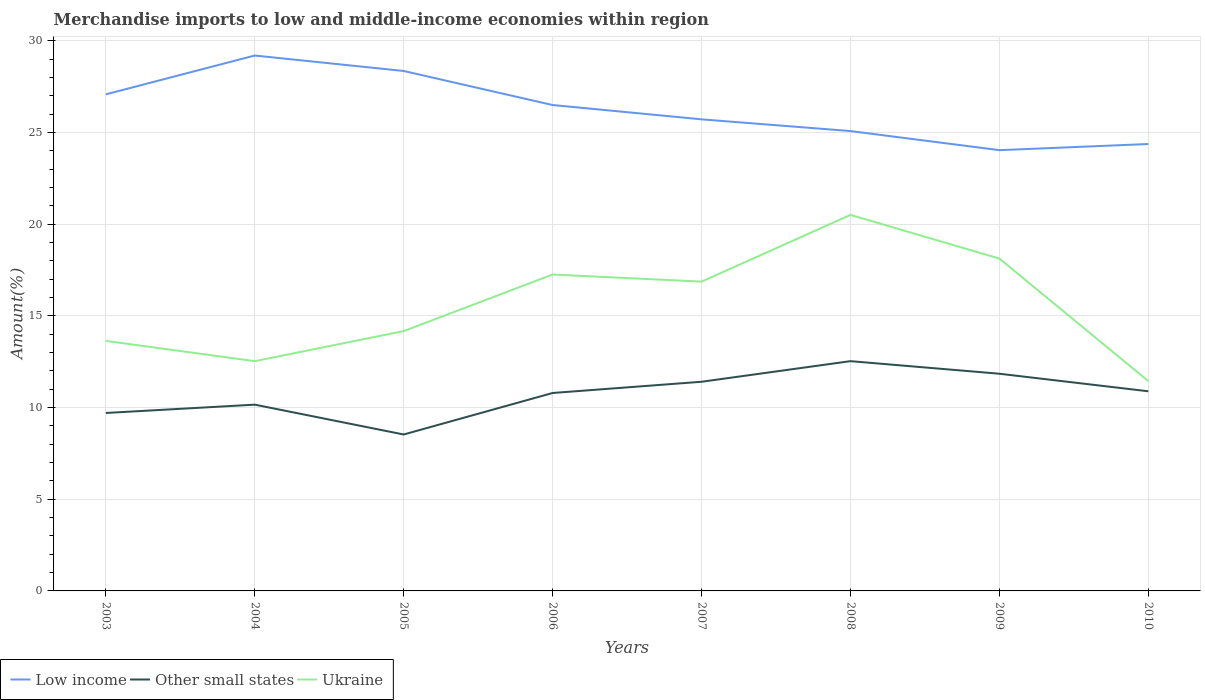How many different coloured lines are there?
Provide a short and direct response. 3. Across all years, what is the maximum percentage of amount earned from merchandise imports in Other small states?
Ensure brevity in your answer.  8.53. What is the total percentage of amount earned from merchandise imports in Ukraine in the graph?
Offer a very short reply. -3.95. What is the difference between the highest and the second highest percentage of amount earned from merchandise imports in Low income?
Your answer should be compact. 5.16. What is the difference between the highest and the lowest percentage of amount earned from merchandise imports in Ukraine?
Make the answer very short. 4. Is the percentage of amount earned from merchandise imports in Low income strictly greater than the percentage of amount earned from merchandise imports in Other small states over the years?
Offer a very short reply. No. Are the values on the major ticks of Y-axis written in scientific E-notation?
Give a very brief answer. No. Does the graph contain any zero values?
Your answer should be compact. No. Does the graph contain grids?
Your answer should be compact. Yes. Where does the legend appear in the graph?
Provide a succinct answer. Bottom left. How many legend labels are there?
Offer a very short reply. 3. What is the title of the graph?
Provide a short and direct response. Merchandise imports to low and middle-income economies within region. What is the label or title of the Y-axis?
Offer a very short reply. Amount(%). What is the Amount(%) of Low income in 2003?
Provide a short and direct response. 27.07. What is the Amount(%) of Other small states in 2003?
Keep it short and to the point. 9.7. What is the Amount(%) of Ukraine in 2003?
Offer a very short reply. 13.63. What is the Amount(%) in Low income in 2004?
Your response must be concise. 29.19. What is the Amount(%) of Other small states in 2004?
Your answer should be compact. 10.16. What is the Amount(%) in Ukraine in 2004?
Make the answer very short. 12.53. What is the Amount(%) of Low income in 2005?
Keep it short and to the point. 28.35. What is the Amount(%) in Other small states in 2005?
Provide a succinct answer. 8.53. What is the Amount(%) of Ukraine in 2005?
Your answer should be very brief. 14.17. What is the Amount(%) in Low income in 2006?
Make the answer very short. 26.49. What is the Amount(%) of Other small states in 2006?
Give a very brief answer. 10.79. What is the Amount(%) in Ukraine in 2006?
Give a very brief answer. 17.25. What is the Amount(%) of Low income in 2007?
Ensure brevity in your answer.  25.71. What is the Amount(%) in Other small states in 2007?
Your answer should be very brief. 11.4. What is the Amount(%) in Ukraine in 2007?
Ensure brevity in your answer.  16.86. What is the Amount(%) in Low income in 2008?
Your answer should be compact. 25.07. What is the Amount(%) in Other small states in 2008?
Your answer should be very brief. 12.53. What is the Amount(%) in Ukraine in 2008?
Ensure brevity in your answer.  20.5. What is the Amount(%) of Low income in 2009?
Keep it short and to the point. 24.03. What is the Amount(%) in Other small states in 2009?
Provide a short and direct response. 11.84. What is the Amount(%) of Ukraine in 2009?
Provide a short and direct response. 18.12. What is the Amount(%) of Low income in 2010?
Offer a very short reply. 24.37. What is the Amount(%) in Other small states in 2010?
Give a very brief answer. 10.88. What is the Amount(%) in Ukraine in 2010?
Provide a short and direct response. 11.44. Across all years, what is the maximum Amount(%) of Low income?
Make the answer very short. 29.19. Across all years, what is the maximum Amount(%) in Other small states?
Your answer should be compact. 12.53. Across all years, what is the maximum Amount(%) in Ukraine?
Provide a succinct answer. 20.5. Across all years, what is the minimum Amount(%) of Low income?
Offer a very short reply. 24.03. Across all years, what is the minimum Amount(%) of Other small states?
Make the answer very short. 8.53. Across all years, what is the minimum Amount(%) in Ukraine?
Your response must be concise. 11.44. What is the total Amount(%) of Low income in the graph?
Your answer should be compact. 210.29. What is the total Amount(%) in Other small states in the graph?
Offer a very short reply. 85.83. What is the total Amount(%) of Ukraine in the graph?
Offer a terse response. 124.5. What is the difference between the Amount(%) in Low income in 2003 and that in 2004?
Keep it short and to the point. -2.12. What is the difference between the Amount(%) in Other small states in 2003 and that in 2004?
Your answer should be compact. -0.45. What is the difference between the Amount(%) in Ukraine in 2003 and that in 2004?
Provide a succinct answer. 1.11. What is the difference between the Amount(%) in Low income in 2003 and that in 2005?
Make the answer very short. -1.27. What is the difference between the Amount(%) in Other small states in 2003 and that in 2005?
Make the answer very short. 1.17. What is the difference between the Amount(%) of Ukraine in 2003 and that in 2005?
Offer a terse response. -0.53. What is the difference between the Amount(%) in Low income in 2003 and that in 2006?
Your answer should be compact. 0.58. What is the difference between the Amount(%) in Other small states in 2003 and that in 2006?
Make the answer very short. -1.09. What is the difference between the Amount(%) in Ukraine in 2003 and that in 2006?
Your answer should be compact. -3.62. What is the difference between the Amount(%) in Low income in 2003 and that in 2007?
Ensure brevity in your answer.  1.36. What is the difference between the Amount(%) of Other small states in 2003 and that in 2007?
Ensure brevity in your answer.  -1.7. What is the difference between the Amount(%) in Ukraine in 2003 and that in 2007?
Your answer should be very brief. -3.23. What is the difference between the Amount(%) of Low income in 2003 and that in 2008?
Keep it short and to the point. 2. What is the difference between the Amount(%) in Other small states in 2003 and that in 2008?
Ensure brevity in your answer.  -2.83. What is the difference between the Amount(%) of Ukraine in 2003 and that in 2008?
Your response must be concise. -6.87. What is the difference between the Amount(%) of Low income in 2003 and that in 2009?
Ensure brevity in your answer.  3.04. What is the difference between the Amount(%) of Other small states in 2003 and that in 2009?
Make the answer very short. -2.14. What is the difference between the Amount(%) in Ukraine in 2003 and that in 2009?
Your response must be concise. -4.49. What is the difference between the Amount(%) in Low income in 2003 and that in 2010?
Your answer should be compact. 2.71. What is the difference between the Amount(%) of Other small states in 2003 and that in 2010?
Keep it short and to the point. -1.18. What is the difference between the Amount(%) of Ukraine in 2003 and that in 2010?
Your answer should be very brief. 2.2. What is the difference between the Amount(%) of Low income in 2004 and that in 2005?
Your response must be concise. 0.84. What is the difference between the Amount(%) of Other small states in 2004 and that in 2005?
Keep it short and to the point. 1.63. What is the difference between the Amount(%) in Ukraine in 2004 and that in 2005?
Provide a short and direct response. -1.64. What is the difference between the Amount(%) of Low income in 2004 and that in 2006?
Offer a very short reply. 2.7. What is the difference between the Amount(%) of Other small states in 2004 and that in 2006?
Keep it short and to the point. -0.64. What is the difference between the Amount(%) in Ukraine in 2004 and that in 2006?
Make the answer very short. -4.72. What is the difference between the Amount(%) in Low income in 2004 and that in 2007?
Provide a succinct answer. 3.48. What is the difference between the Amount(%) of Other small states in 2004 and that in 2007?
Ensure brevity in your answer.  -1.25. What is the difference between the Amount(%) of Ukraine in 2004 and that in 2007?
Your answer should be compact. -4.34. What is the difference between the Amount(%) in Low income in 2004 and that in 2008?
Offer a terse response. 4.12. What is the difference between the Amount(%) of Other small states in 2004 and that in 2008?
Your response must be concise. -2.37. What is the difference between the Amount(%) of Ukraine in 2004 and that in 2008?
Your response must be concise. -7.97. What is the difference between the Amount(%) of Low income in 2004 and that in 2009?
Ensure brevity in your answer.  5.16. What is the difference between the Amount(%) of Other small states in 2004 and that in 2009?
Ensure brevity in your answer.  -1.69. What is the difference between the Amount(%) of Ukraine in 2004 and that in 2009?
Your answer should be very brief. -5.59. What is the difference between the Amount(%) in Low income in 2004 and that in 2010?
Provide a short and direct response. 4.82. What is the difference between the Amount(%) in Other small states in 2004 and that in 2010?
Provide a short and direct response. -0.73. What is the difference between the Amount(%) in Ukraine in 2004 and that in 2010?
Your response must be concise. 1.09. What is the difference between the Amount(%) in Low income in 2005 and that in 2006?
Give a very brief answer. 1.86. What is the difference between the Amount(%) in Other small states in 2005 and that in 2006?
Your response must be concise. -2.26. What is the difference between the Amount(%) in Ukraine in 2005 and that in 2006?
Make the answer very short. -3.08. What is the difference between the Amount(%) in Low income in 2005 and that in 2007?
Keep it short and to the point. 2.64. What is the difference between the Amount(%) of Other small states in 2005 and that in 2007?
Provide a succinct answer. -2.88. What is the difference between the Amount(%) of Ukraine in 2005 and that in 2007?
Provide a succinct answer. -2.7. What is the difference between the Amount(%) in Low income in 2005 and that in 2008?
Your response must be concise. 3.28. What is the difference between the Amount(%) in Other small states in 2005 and that in 2008?
Your response must be concise. -4. What is the difference between the Amount(%) of Ukraine in 2005 and that in 2008?
Provide a short and direct response. -6.33. What is the difference between the Amount(%) in Low income in 2005 and that in 2009?
Provide a short and direct response. 4.32. What is the difference between the Amount(%) of Other small states in 2005 and that in 2009?
Your answer should be very brief. -3.31. What is the difference between the Amount(%) of Ukraine in 2005 and that in 2009?
Give a very brief answer. -3.95. What is the difference between the Amount(%) in Low income in 2005 and that in 2010?
Ensure brevity in your answer.  3.98. What is the difference between the Amount(%) in Other small states in 2005 and that in 2010?
Ensure brevity in your answer.  -2.36. What is the difference between the Amount(%) of Ukraine in 2005 and that in 2010?
Offer a very short reply. 2.73. What is the difference between the Amount(%) of Low income in 2006 and that in 2007?
Ensure brevity in your answer.  0.78. What is the difference between the Amount(%) in Other small states in 2006 and that in 2007?
Your answer should be very brief. -0.61. What is the difference between the Amount(%) in Ukraine in 2006 and that in 2007?
Your answer should be very brief. 0.39. What is the difference between the Amount(%) in Low income in 2006 and that in 2008?
Give a very brief answer. 1.42. What is the difference between the Amount(%) of Other small states in 2006 and that in 2008?
Offer a very short reply. -1.74. What is the difference between the Amount(%) in Ukraine in 2006 and that in 2008?
Offer a terse response. -3.25. What is the difference between the Amount(%) of Low income in 2006 and that in 2009?
Your answer should be compact. 2.46. What is the difference between the Amount(%) in Other small states in 2006 and that in 2009?
Your answer should be compact. -1.05. What is the difference between the Amount(%) in Ukraine in 2006 and that in 2009?
Offer a terse response. -0.87. What is the difference between the Amount(%) of Low income in 2006 and that in 2010?
Give a very brief answer. 2.13. What is the difference between the Amount(%) in Other small states in 2006 and that in 2010?
Your answer should be compact. -0.09. What is the difference between the Amount(%) of Ukraine in 2006 and that in 2010?
Make the answer very short. 5.81. What is the difference between the Amount(%) in Low income in 2007 and that in 2008?
Provide a short and direct response. 0.64. What is the difference between the Amount(%) in Other small states in 2007 and that in 2008?
Your answer should be very brief. -1.12. What is the difference between the Amount(%) in Ukraine in 2007 and that in 2008?
Make the answer very short. -3.64. What is the difference between the Amount(%) of Low income in 2007 and that in 2009?
Offer a very short reply. 1.68. What is the difference between the Amount(%) of Other small states in 2007 and that in 2009?
Ensure brevity in your answer.  -0.44. What is the difference between the Amount(%) of Ukraine in 2007 and that in 2009?
Make the answer very short. -1.26. What is the difference between the Amount(%) in Low income in 2007 and that in 2010?
Make the answer very short. 1.35. What is the difference between the Amount(%) in Other small states in 2007 and that in 2010?
Your answer should be compact. 0.52. What is the difference between the Amount(%) in Ukraine in 2007 and that in 2010?
Offer a terse response. 5.43. What is the difference between the Amount(%) of Low income in 2008 and that in 2009?
Your response must be concise. 1.04. What is the difference between the Amount(%) in Other small states in 2008 and that in 2009?
Your answer should be compact. 0.69. What is the difference between the Amount(%) of Ukraine in 2008 and that in 2009?
Give a very brief answer. 2.38. What is the difference between the Amount(%) of Low income in 2008 and that in 2010?
Give a very brief answer. 0.71. What is the difference between the Amount(%) in Other small states in 2008 and that in 2010?
Offer a terse response. 1.64. What is the difference between the Amount(%) of Ukraine in 2008 and that in 2010?
Ensure brevity in your answer.  9.06. What is the difference between the Amount(%) of Low income in 2009 and that in 2010?
Keep it short and to the point. -0.33. What is the difference between the Amount(%) in Other small states in 2009 and that in 2010?
Offer a terse response. 0.96. What is the difference between the Amount(%) in Ukraine in 2009 and that in 2010?
Offer a terse response. 6.68. What is the difference between the Amount(%) in Low income in 2003 and the Amount(%) in Other small states in 2004?
Make the answer very short. 16.92. What is the difference between the Amount(%) of Low income in 2003 and the Amount(%) of Ukraine in 2004?
Ensure brevity in your answer.  14.55. What is the difference between the Amount(%) in Other small states in 2003 and the Amount(%) in Ukraine in 2004?
Keep it short and to the point. -2.82. What is the difference between the Amount(%) in Low income in 2003 and the Amount(%) in Other small states in 2005?
Your response must be concise. 18.55. What is the difference between the Amount(%) of Low income in 2003 and the Amount(%) of Ukraine in 2005?
Your answer should be compact. 12.91. What is the difference between the Amount(%) in Other small states in 2003 and the Amount(%) in Ukraine in 2005?
Your response must be concise. -4.47. What is the difference between the Amount(%) of Low income in 2003 and the Amount(%) of Other small states in 2006?
Your answer should be very brief. 16.28. What is the difference between the Amount(%) of Low income in 2003 and the Amount(%) of Ukraine in 2006?
Offer a very short reply. 9.82. What is the difference between the Amount(%) in Other small states in 2003 and the Amount(%) in Ukraine in 2006?
Your response must be concise. -7.55. What is the difference between the Amount(%) of Low income in 2003 and the Amount(%) of Other small states in 2007?
Provide a succinct answer. 15.67. What is the difference between the Amount(%) of Low income in 2003 and the Amount(%) of Ukraine in 2007?
Your response must be concise. 10.21. What is the difference between the Amount(%) of Other small states in 2003 and the Amount(%) of Ukraine in 2007?
Provide a short and direct response. -7.16. What is the difference between the Amount(%) of Low income in 2003 and the Amount(%) of Other small states in 2008?
Provide a short and direct response. 14.55. What is the difference between the Amount(%) in Low income in 2003 and the Amount(%) in Ukraine in 2008?
Offer a terse response. 6.57. What is the difference between the Amount(%) in Other small states in 2003 and the Amount(%) in Ukraine in 2008?
Offer a very short reply. -10.8. What is the difference between the Amount(%) of Low income in 2003 and the Amount(%) of Other small states in 2009?
Make the answer very short. 15.23. What is the difference between the Amount(%) of Low income in 2003 and the Amount(%) of Ukraine in 2009?
Provide a short and direct response. 8.95. What is the difference between the Amount(%) in Other small states in 2003 and the Amount(%) in Ukraine in 2009?
Provide a succinct answer. -8.42. What is the difference between the Amount(%) in Low income in 2003 and the Amount(%) in Other small states in 2010?
Give a very brief answer. 16.19. What is the difference between the Amount(%) of Low income in 2003 and the Amount(%) of Ukraine in 2010?
Your answer should be compact. 15.64. What is the difference between the Amount(%) in Other small states in 2003 and the Amount(%) in Ukraine in 2010?
Keep it short and to the point. -1.74. What is the difference between the Amount(%) of Low income in 2004 and the Amount(%) of Other small states in 2005?
Give a very brief answer. 20.66. What is the difference between the Amount(%) in Low income in 2004 and the Amount(%) in Ukraine in 2005?
Keep it short and to the point. 15.02. What is the difference between the Amount(%) of Other small states in 2004 and the Amount(%) of Ukraine in 2005?
Your answer should be very brief. -4.01. What is the difference between the Amount(%) in Low income in 2004 and the Amount(%) in Other small states in 2006?
Offer a very short reply. 18.4. What is the difference between the Amount(%) in Low income in 2004 and the Amount(%) in Ukraine in 2006?
Give a very brief answer. 11.94. What is the difference between the Amount(%) in Other small states in 2004 and the Amount(%) in Ukraine in 2006?
Provide a succinct answer. -7.09. What is the difference between the Amount(%) in Low income in 2004 and the Amount(%) in Other small states in 2007?
Make the answer very short. 17.79. What is the difference between the Amount(%) in Low income in 2004 and the Amount(%) in Ukraine in 2007?
Give a very brief answer. 12.33. What is the difference between the Amount(%) in Other small states in 2004 and the Amount(%) in Ukraine in 2007?
Provide a short and direct response. -6.71. What is the difference between the Amount(%) of Low income in 2004 and the Amount(%) of Other small states in 2008?
Make the answer very short. 16.66. What is the difference between the Amount(%) in Low income in 2004 and the Amount(%) in Ukraine in 2008?
Provide a short and direct response. 8.69. What is the difference between the Amount(%) in Other small states in 2004 and the Amount(%) in Ukraine in 2008?
Offer a terse response. -10.35. What is the difference between the Amount(%) in Low income in 2004 and the Amount(%) in Other small states in 2009?
Give a very brief answer. 17.35. What is the difference between the Amount(%) in Low income in 2004 and the Amount(%) in Ukraine in 2009?
Keep it short and to the point. 11.07. What is the difference between the Amount(%) of Other small states in 2004 and the Amount(%) of Ukraine in 2009?
Your answer should be very brief. -7.96. What is the difference between the Amount(%) in Low income in 2004 and the Amount(%) in Other small states in 2010?
Offer a terse response. 18.31. What is the difference between the Amount(%) of Low income in 2004 and the Amount(%) of Ukraine in 2010?
Provide a succinct answer. 17.75. What is the difference between the Amount(%) of Other small states in 2004 and the Amount(%) of Ukraine in 2010?
Ensure brevity in your answer.  -1.28. What is the difference between the Amount(%) in Low income in 2005 and the Amount(%) in Other small states in 2006?
Your response must be concise. 17.56. What is the difference between the Amount(%) in Low income in 2005 and the Amount(%) in Ukraine in 2006?
Give a very brief answer. 11.1. What is the difference between the Amount(%) in Other small states in 2005 and the Amount(%) in Ukraine in 2006?
Your response must be concise. -8.72. What is the difference between the Amount(%) of Low income in 2005 and the Amount(%) of Other small states in 2007?
Provide a short and direct response. 16.94. What is the difference between the Amount(%) of Low income in 2005 and the Amount(%) of Ukraine in 2007?
Provide a short and direct response. 11.48. What is the difference between the Amount(%) of Other small states in 2005 and the Amount(%) of Ukraine in 2007?
Ensure brevity in your answer.  -8.34. What is the difference between the Amount(%) of Low income in 2005 and the Amount(%) of Other small states in 2008?
Offer a terse response. 15.82. What is the difference between the Amount(%) of Low income in 2005 and the Amount(%) of Ukraine in 2008?
Your answer should be very brief. 7.85. What is the difference between the Amount(%) in Other small states in 2005 and the Amount(%) in Ukraine in 2008?
Your answer should be compact. -11.97. What is the difference between the Amount(%) in Low income in 2005 and the Amount(%) in Other small states in 2009?
Give a very brief answer. 16.51. What is the difference between the Amount(%) of Low income in 2005 and the Amount(%) of Ukraine in 2009?
Your response must be concise. 10.23. What is the difference between the Amount(%) of Other small states in 2005 and the Amount(%) of Ukraine in 2009?
Give a very brief answer. -9.59. What is the difference between the Amount(%) of Low income in 2005 and the Amount(%) of Other small states in 2010?
Keep it short and to the point. 17.46. What is the difference between the Amount(%) of Low income in 2005 and the Amount(%) of Ukraine in 2010?
Give a very brief answer. 16.91. What is the difference between the Amount(%) in Other small states in 2005 and the Amount(%) in Ukraine in 2010?
Your answer should be compact. -2.91. What is the difference between the Amount(%) of Low income in 2006 and the Amount(%) of Other small states in 2007?
Your response must be concise. 15.09. What is the difference between the Amount(%) in Low income in 2006 and the Amount(%) in Ukraine in 2007?
Your answer should be very brief. 9.63. What is the difference between the Amount(%) in Other small states in 2006 and the Amount(%) in Ukraine in 2007?
Your answer should be compact. -6.07. What is the difference between the Amount(%) of Low income in 2006 and the Amount(%) of Other small states in 2008?
Your answer should be very brief. 13.96. What is the difference between the Amount(%) of Low income in 2006 and the Amount(%) of Ukraine in 2008?
Offer a terse response. 5.99. What is the difference between the Amount(%) of Other small states in 2006 and the Amount(%) of Ukraine in 2008?
Your answer should be very brief. -9.71. What is the difference between the Amount(%) of Low income in 2006 and the Amount(%) of Other small states in 2009?
Your response must be concise. 14.65. What is the difference between the Amount(%) of Low income in 2006 and the Amount(%) of Ukraine in 2009?
Make the answer very short. 8.37. What is the difference between the Amount(%) of Other small states in 2006 and the Amount(%) of Ukraine in 2009?
Provide a short and direct response. -7.33. What is the difference between the Amount(%) in Low income in 2006 and the Amount(%) in Other small states in 2010?
Your answer should be compact. 15.61. What is the difference between the Amount(%) in Low income in 2006 and the Amount(%) in Ukraine in 2010?
Keep it short and to the point. 15.05. What is the difference between the Amount(%) in Other small states in 2006 and the Amount(%) in Ukraine in 2010?
Provide a succinct answer. -0.65. What is the difference between the Amount(%) in Low income in 2007 and the Amount(%) in Other small states in 2008?
Your answer should be very brief. 13.18. What is the difference between the Amount(%) in Low income in 2007 and the Amount(%) in Ukraine in 2008?
Your response must be concise. 5.21. What is the difference between the Amount(%) in Other small states in 2007 and the Amount(%) in Ukraine in 2008?
Offer a terse response. -9.1. What is the difference between the Amount(%) in Low income in 2007 and the Amount(%) in Other small states in 2009?
Your answer should be very brief. 13.87. What is the difference between the Amount(%) in Low income in 2007 and the Amount(%) in Ukraine in 2009?
Your response must be concise. 7.59. What is the difference between the Amount(%) in Other small states in 2007 and the Amount(%) in Ukraine in 2009?
Offer a very short reply. -6.72. What is the difference between the Amount(%) in Low income in 2007 and the Amount(%) in Other small states in 2010?
Your answer should be very brief. 14.83. What is the difference between the Amount(%) of Low income in 2007 and the Amount(%) of Ukraine in 2010?
Offer a terse response. 14.27. What is the difference between the Amount(%) of Other small states in 2007 and the Amount(%) of Ukraine in 2010?
Offer a very short reply. -0.03. What is the difference between the Amount(%) in Low income in 2008 and the Amount(%) in Other small states in 2009?
Your answer should be compact. 13.23. What is the difference between the Amount(%) in Low income in 2008 and the Amount(%) in Ukraine in 2009?
Your response must be concise. 6.95. What is the difference between the Amount(%) of Other small states in 2008 and the Amount(%) of Ukraine in 2009?
Give a very brief answer. -5.59. What is the difference between the Amount(%) of Low income in 2008 and the Amount(%) of Other small states in 2010?
Provide a succinct answer. 14.19. What is the difference between the Amount(%) in Low income in 2008 and the Amount(%) in Ukraine in 2010?
Your answer should be compact. 13.64. What is the difference between the Amount(%) of Other small states in 2008 and the Amount(%) of Ukraine in 2010?
Provide a short and direct response. 1.09. What is the difference between the Amount(%) of Low income in 2009 and the Amount(%) of Other small states in 2010?
Make the answer very short. 13.15. What is the difference between the Amount(%) of Low income in 2009 and the Amount(%) of Ukraine in 2010?
Keep it short and to the point. 12.59. What is the difference between the Amount(%) in Other small states in 2009 and the Amount(%) in Ukraine in 2010?
Provide a succinct answer. 0.4. What is the average Amount(%) of Low income per year?
Offer a very short reply. 26.29. What is the average Amount(%) in Other small states per year?
Ensure brevity in your answer.  10.73. What is the average Amount(%) in Ukraine per year?
Your response must be concise. 15.56. In the year 2003, what is the difference between the Amount(%) in Low income and Amount(%) in Other small states?
Give a very brief answer. 17.37. In the year 2003, what is the difference between the Amount(%) of Low income and Amount(%) of Ukraine?
Give a very brief answer. 13.44. In the year 2003, what is the difference between the Amount(%) of Other small states and Amount(%) of Ukraine?
Offer a terse response. -3.93. In the year 2004, what is the difference between the Amount(%) in Low income and Amount(%) in Other small states?
Your response must be concise. 19.04. In the year 2004, what is the difference between the Amount(%) in Low income and Amount(%) in Ukraine?
Offer a terse response. 16.66. In the year 2004, what is the difference between the Amount(%) of Other small states and Amount(%) of Ukraine?
Your response must be concise. -2.37. In the year 2005, what is the difference between the Amount(%) in Low income and Amount(%) in Other small states?
Offer a very short reply. 19.82. In the year 2005, what is the difference between the Amount(%) in Low income and Amount(%) in Ukraine?
Your answer should be very brief. 14.18. In the year 2005, what is the difference between the Amount(%) in Other small states and Amount(%) in Ukraine?
Ensure brevity in your answer.  -5.64. In the year 2006, what is the difference between the Amount(%) of Low income and Amount(%) of Other small states?
Provide a short and direct response. 15.7. In the year 2006, what is the difference between the Amount(%) in Low income and Amount(%) in Ukraine?
Offer a terse response. 9.24. In the year 2006, what is the difference between the Amount(%) in Other small states and Amount(%) in Ukraine?
Offer a terse response. -6.46. In the year 2007, what is the difference between the Amount(%) of Low income and Amount(%) of Other small states?
Ensure brevity in your answer.  14.31. In the year 2007, what is the difference between the Amount(%) of Low income and Amount(%) of Ukraine?
Your response must be concise. 8.85. In the year 2007, what is the difference between the Amount(%) in Other small states and Amount(%) in Ukraine?
Give a very brief answer. -5.46. In the year 2008, what is the difference between the Amount(%) of Low income and Amount(%) of Other small states?
Offer a very short reply. 12.54. In the year 2008, what is the difference between the Amount(%) in Low income and Amount(%) in Ukraine?
Your response must be concise. 4.57. In the year 2008, what is the difference between the Amount(%) of Other small states and Amount(%) of Ukraine?
Your response must be concise. -7.97. In the year 2009, what is the difference between the Amount(%) of Low income and Amount(%) of Other small states?
Your answer should be compact. 12.19. In the year 2009, what is the difference between the Amount(%) in Low income and Amount(%) in Ukraine?
Provide a succinct answer. 5.91. In the year 2009, what is the difference between the Amount(%) of Other small states and Amount(%) of Ukraine?
Provide a short and direct response. -6.28. In the year 2010, what is the difference between the Amount(%) in Low income and Amount(%) in Other small states?
Provide a succinct answer. 13.48. In the year 2010, what is the difference between the Amount(%) in Low income and Amount(%) in Ukraine?
Provide a short and direct response. 12.93. In the year 2010, what is the difference between the Amount(%) of Other small states and Amount(%) of Ukraine?
Your answer should be very brief. -0.55. What is the ratio of the Amount(%) in Low income in 2003 to that in 2004?
Keep it short and to the point. 0.93. What is the ratio of the Amount(%) of Other small states in 2003 to that in 2004?
Offer a very short reply. 0.96. What is the ratio of the Amount(%) of Ukraine in 2003 to that in 2004?
Provide a short and direct response. 1.09. What is the ratio of the Amount(%) in Low income in 2003 to that in 2005?
Your answer should be compact. 0.96. What is the ratio of the Amount(%) of Other small states in 2003 to that in 2005?
Your response must be concise. 1.14. What is the ratio of the Amount(%) of Ukraine in 2003 to that in 2005?
Your response must be concise. 0.96. What is the ratio of the Amount(%) in Other small states in 2003 to that in 2006?
Your response must be concise. 0.9. What is the ratio of the Amount(%) of Ukraine in 2003 to that in 2006?
Make the answer very short. 0.79. What is the ratio of the Amount(%) of Low income in 2003 to that in 2007?
Make the answer very short. 1.05. What is the ratio of the Amount(%) of Other small states in 2003 to that in 2007?
Give a very brief answer. 0.85. What is the ratio of the Amount(%) in Ukraine in 2003 to that in 2007?
Your answer should be compact. 0.81. What is the ratio of the Amount(%) of Low income in 2003 to that in 2008?
Provide a short and direct response. 1.08. What is the ratio of the Amount(%) in Other small states in 2003 to that in 2008?
Ensure brevity in your answer.  0.77. What is the ratio of the Amount(%) in Ukraine in 2003 to that in 2008?
Your answer should be compact. 0.67. What is the ratio of the Amount(%) of Low income in 2003 to that in 2009?
Offer a terse response. 1.13. What is the ratio of the Amount(%) of Other small states in 2003 to that in 2009?
Provide a succinct answer. 0.82. What is the ratio of the Amount(%) of Ukraine in 2003 to that in 2009?
Your answer should be compact. 0.75. What is the ratio of the Amount(%) in Low income in 2003 to that in 2010?
Your answer should be compact. 1.11. What is the ratio of the Amount(%) of Other small states in 2003 to that in 2010?
Ensure brevity in your answer.  0.89. What is the ratio of the Amount(%) in Ukraine in 2003 to that in 2010?
Your answer should be very brief. 1.19. What is the ratio of the Amount(%) of Low income in 2004 to that in 2005?
Ensure brevity in your answer.  1.03. What is the ratio of the Amount(%) of Other small states in 2004 to that in 2005?
Your answer should be very brief. 1.19. What is the ratio of the Amount(%) in Ukraine in 2004 to that in 2005?
Your answer should be very brief. 0.88. What is the ratio of the Amount(%) in Low income in 2004 to that in 2006?
Your answer should be very brief. 1.1. What is the ratio of the Amount(%) in Other small states in 2004 to that in 2006?
Ensure brevity in your answer.  0.94. What is the ratio of the Amount(%) in Ukraine in 2004 to that in 2006?
Make the answer very short. 0.73. What is the ratio of the Amount(%) in Low income in 2004 to that in 2007?
Your response must be concise. 1.14. What is the ratio of the Amount(%) in Other small states in 2004 to that in 2007?
Provide a short and direct response. 0.89. What is the ratio of the Amount(%) in Ukraine in 2004 to that in 2007?
Ensure brevity in your answer.  0.74. What is the ratio of the Amount(%) in Low income in 2004 to that in 2008?
Keep it short and to the point. 1.16. What is the ratio of the Amount(%) of Other small states in 2004 to that in 2008?
Offer a terse response. 0.81. What is the ratio of the Amount(%) of Ukraine in 2004 to that in 2008?
Your answer should be compact. 0.61. What is the ratio of the Amount(%) of Low income in 2004 to that in 2009?
Your answer should be very brief. 1.21. What is the ratio of the Amount(%) of Other small states in 2004 to that in 2009?
Your answer should be very brief. 0.86. What is the ratio of the Amount(%) of Ukraine in 2004 to that in 2009?
Ensure brevity in your answer.  0.69. What is the ratio of the Amount(%) in Low income in 2004 to that in 2010?
Offer a terse response. 1.2. What is the ratio of the Amount(%) in Other small states in 2004 to that in 2010?
Provide a succinct answer. 0.93. What is the ratio of the Amount(%) in Ukraine in 2004 to that in 2010?
Provide a short and direct response. 1.1. What is the ratio of the Amount(%) of Low income in 2005 to that in 2006?
Provide a short and direct response. 1.07. What is the ratio of the Amount(%) in Other small states in 2005 to that in 2006?
Make the answer very short. 0.79. What is the ratio of the Amount(%) of Ukraine in 2005 to that in 2006?
Your answer should be very brief. 0.82. What is the ratio of the Amount(%) of Low income in 2005 to that in 2007?
Your answer should be compact. 1.1. What is the ratio of the Amount(%) of Other small states in 2005 to that in 2007?
Offer a very short reply. 0.75. What is the ratio of the Amount(%) in Ukraine in 2005 to that in 2007?
Offer a very short reply. 0.84. What is the ratio of the Amount(%) in Low income in 2005 to that in 2008?
Provide a succinct answer. 1.13. What is the ratio of the Amount(%) of Other small states in 2005 to that in 2008?
Give a very brief answer. 0.68. What is the ratio of the Amount(%) in Ukraine in 2005 to that in 2008?
Ensure brevity in your answer.  0.69. What is the ratio of the Amount(%) in Low income in 2005 to that in 2009?
Offer a very short reply. 1.18. What is the ratio of the Amount(%) of Other small states in 2005 to that in 2009?
Your answer should be very brief. 0.72. What is the ratio of the Amount(%) of Ukraine in 2005 to that in 2009?
Offer a terse response. 0.78. What is the ratio of the Amount(%) of Low income in 2005 to that in 2010?
Give a very brief answer. 1.16. What is the ratio of the Amount(%) of Other small states in 2005 to that in 2010?
Give a very brief answer. 0.78. What is the ratio of the Amount(%) of Ukraine in 2005 to that in 2010?
Make the answer very short. 1.24. What is the ratio of the Amount(%) of Low income in 2006 to that in 2007?
Make the answer very short. 1.03. What is the ratio of the Amount(%) of Other small states in 2006 to that in 2007?
Your answer should be compact. 0.95. What is the ratio of the Amount(%) of Ukraine in 2006 to that in 2007?
Offer a terse response. 1.02. What is the ratio of the Amount(%) of Low income in 2006 to that in 2008?
Provide a succinct answer. 1.06. What is the ratio of the Amount(%) in Other small states in 2006 to that in 2008?
Your answer should be very brief. 0.86. What is the ratio of the Amount(%) in Ukraine in 2006 to that in 2008?
Provide a short and direct response. 0.84. What is the ratio of the Amount(%) in Low income in 2006 to that in 2009?
Keep it short and to the point. 1.1. What is the ratio of the Amount(%) of Other small states in 2006 to that in 2009?
Your response must be concise. 0.91. What is the ratio of the Amount(%) in Ukraine in 2006 to that in 2009?
Your response must be concise. 0.95. What is the ratio of the Amount(%) of Low income in 2006 to that in 2010?
Offer a very short reply. 1.09. What is the ratio of the Amount(%) of Ukraine in 2006 to that in 2010?
Give a very brief answer. 1.51. What is the ratio of the Amount(%) of Low income in 2007 to that in 2008?
Your answer should be very brief. 1.03. What is the ratio of the Amount(%) of Other small states in 2007 to that in 2008?
Give a very brief answer. 0.91. What is the ratio of the Amount(%) of Ukraine in 2007 to that in 2008?
Your answer should be very brief. 0.82. What is the ratio of the Amount(%) in Low income in 2007 to that in 2009?
Give a very brief answer. 1.07. What is the ratio of the Amount(%) of Other small states in 2007 to that in 2009?
Offer a very short reply. 0.96. What is the ratio of the Amount(%) of Ukraine in 2007 to that in 2009?
Your answer should be compact. 0.93. What is the ratio of the Amount(%) of Low income in 2007 to that in 2010?
Give a very brief answer. 1.06. What is the ratio of the Amount(%) of Other small states in 2007 to that in 2010?
Give a very brief answer. 1.05. What is the ratio of the Amount(%) of Ukraine in 2007 to that in 2010?
Offer a very short reply. 1.47. What is the ratio of the Amount(%) of Low income in 2008 to that in 2009?
Offer a terse response. 1.04. What is the ratio of the Amount(%) of Other small states in 2008 to that in 2009?
Your answer should be compact. 1.06. What is the ratio of the Amount(%) in Ukraine in 2008 to that in 2009?
Provide a succinct answer. 1.13. What is the ratio of the Amount(%) of Low income in 2008 to that in 2010?
Provide a succinct answer. 1.03. What is the ratio of the Amount(%) of Other small states in 2008 to that in 2010?
Your answer should be very brief. 1.15. What is the ratio of the Amount(%) of Ukraine in 2008 to that in 2010?
Your answer should be compact. 1.79. What is the ratio of the Amount(%) of Low income in 2009 to that in 2010?
Make the answer very short. 0.99. What is the ratio of the Amount(%) in Other small states in 2009 to that in 2010?
Ensure brevity in your answer.  1.09. What is the ratio of the Amount(%) of Ukraine in 2009 to that in 2010?
Keep it short and to the point. 1.58. What is the difference between the highest and the second highest Amount(%) of Low income?
Keep it short and to the point. 0.84. What is the difference between the highest and the second highest Amount(%) of Other small states?
Offer a terse response. 0.69. What is the difference between the highest and the second highest Amount(%) in Ukraine?
Keep it short and to the point. 2.38. What is the difference between the highest and the lowest Amount(%) in Low income?
Your answer should be compact. 5.16. What is the difference between the highest and the lowest Amount(%) of Other small states?
Provide a short and direct response. 4. What is the difference between the highest and the lowest Amount(%) in Ukraine?
Provide a succinct answer. 9.06. 